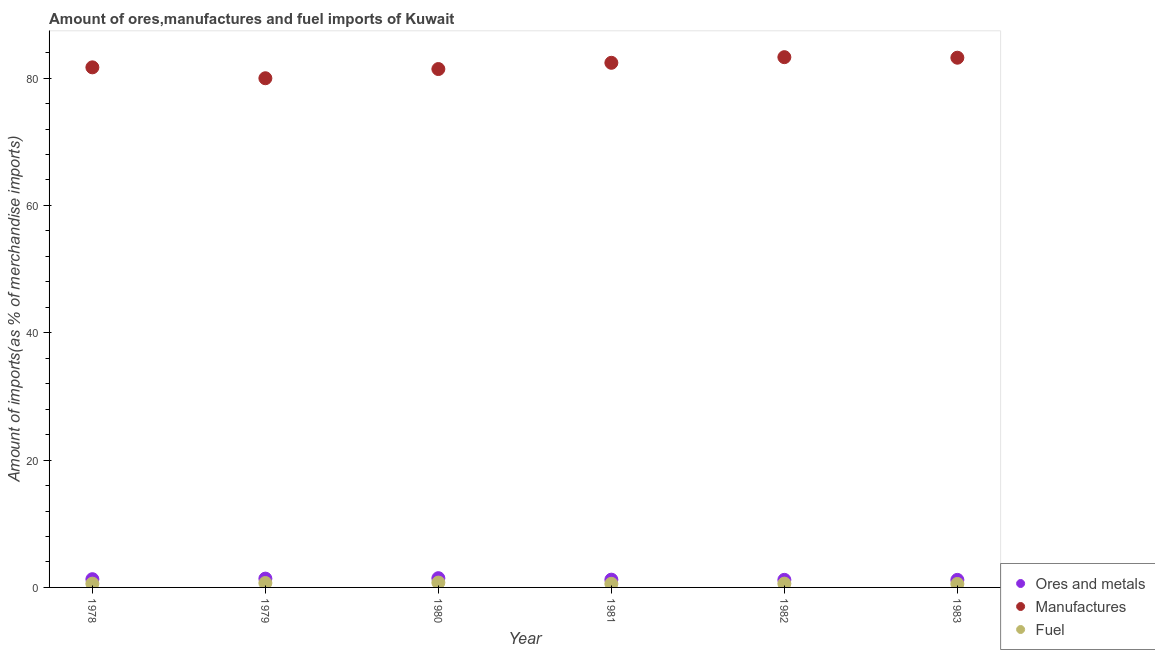Is the number of dotlines equal to the number of legend labels?
Offer a very short reply. Yes. What is the percentage of fuel imports in 1978?
Keep it short and to the point. 0.59. Across all years, what is the maximum percentage of fuel imports?
Your answer should be compact. 0.76. Across all years, what is the minimum percentage of fuel imports?
Your answer should be compact. 0.54. What is the total percentage of ores and metals imports in the graph?
Provide a short and direct response. 7.72. What is the difference between the percentage of ores and metals imports in 1980 and that in 1983?
Your response must be concise. 0.27. What is the difference between the percentage of manufactures imports in 1981 and the percentage of fuel imports in 1983?
Offer a very short reply. 81.86. What is the average percentage of fuel imports per year?
Give a very brief answer. 0.63. In the year 1978, what is the difference between the percentage of manufactures imports and percentage of ores and metals imports?
Give a very brief answer. 80.4. In how many years, is the percentage of ores and metals imports greater than 44 %?
Offer a very short reply. 0. What is the ratio of the percentage of fuel imports in 1979 to that in 1982?
Give a very brief answer. 1.16. Is the percentage of manufactures imports in 1979 less than that in 1982?
Provide a succinct answer. Yes. What is the difference between the highest and the second highest percentage of manufactures imports?
Your response must be concise. 0.08. What is the difference between the highest and the lowest percentage of ores and metals imports?
Keep it short and to the point. 0.27. Is the sum of the percentage of ores and metals imports in 1978 and 1979 greater than the maximum percentage of manufactures imports across all years?
Offer a very short reply. No. Is it the case that in every year, the sum of the percentage of ores and metals imports and percentage of manufactures imports is greater than the percentage of fuel imports?
Offer a very short reply. Yes. Does the percentage of fuel imports monotonically increase over the years?
Provide a succinct answer. No. Is the percentage of manufactures imports strictly greater than the percentage of ores and metals imports over the years?
Ensure brevity in your answer.  Yes. Is the percentage of manufactures imports strictly less than the percentage of ores and metals imports over the years?
Your answer should be very brief. No. How many years are there in the graph?
Your answer should be very brief. 6. Are the values on the major ticks of Y-axis written in scientific E-notation?
Give a very brief answer. No. Does the graph contain grids?
Keep it short and to the point. No. How many legend labels are there?
Provide a short and direct response. 3. How are the legend labels stacked?
Offer a very short reply. Vertical. What is the title of the graph?
Your answer should be very brief. Amount of ores,manufactures and fuel imports of Kuwait. What is the label or title of the X-axis?
Provide a short and direct response. Year. What is the label or title of the Y-axis?
Give a very brief answer. Amount of imports(as % of merchandise imports). What is the Amount of imports(as % of merchandise imports) in Ores and metals in 1978?
Provide a short and direct response. 1.29. What is the Amount of imports(as % of merchandise imports) of Manufactures in 1978?
Your response must be concise. 81.69. What is the Amount of imports(as % of merchandise imports) in Fuel in 1978?
Your response must be concise. 0.59. What is the Amount of imports(as % of merchandise imports) in Ores and metals in 1979?
Provide a short and direct response. 1.38. What is the Amount of imports(as % of merchandise imports) in Manufactures in 1979?
Provide a succinct answer. 79.98. What is the Amount of imports(as % of merchandise imports) of Fuel in 1979?
Your answer should be compact. 0.69. What is the Amount of imports(as % of merchandise imports) of Ores and metals in 1980?
Give a very brief answer. 1.45. What is the Amount of imports(as % of merchandise imports) of Manufactures in 1980?
Offer a very short reply. 81.43. What is the Amount of imports(as % of merchandise imports) in Fuel in 1980?
Provide a succinct answer. 0.76. What is the Amount of imports(as % of merchandise imports) in Ores and metals in 1981?
Your answer should be compact. 1.22. What is the Amount of imports(as % of merchandise imports) in Manufactures in 1981?
Provide a short and direct response. 82.41. What is the Amount of imports(as % of merchandise imports) in Fuel in 1981?
Your answer should be very brief. 0.57. What is the Amount of imports(as % of merchandise imports) in Ores and metals in 1982?
Your answer should be very brief. 1.19. What is the Amount of imports(as % of merchandise imports) in Manufactures in 1982?
Ensure brevity in your answer.  83.29. What is the Amount of imports(as % of merchandise imports) in Fuel in 1982?
Ensure brevity in your answer.  0.6. What is the Amount of imports(as % of merchandise imports) in Ores and metals in 1983?
Offer a very short reply. 1.19. What is the Amount of imports(as % of merchandise imports) in Manufactures in 1983?
Provide a succinct answer. 83.21. What is the Amount of imports(as % of merchandise imports) of Fuel in 1983?
Offer a terse response. 0.54. Across all years, what is the maximum Amount of imports(as % of merchandise imports) of Ores and metals?
Offer a very short reply. 1.45. Across all years, what is the maximum Amount of imports(as % of merchandise imports) of Manufactures?
Provide a short and direct response. 83.29. Across all years, what is the maximum Amount of imports(as % of merchandise imports) in Fuel?
Ensure brevity in your answer.  0.76. Across all years, what is the minimum Amount of imports(as % of merchandise imports) in Ores and metals?
Ensure brevity in your answer.  1.19. Across all years, what is the minimum Amount of imports(as % of merchandise imports) of Manufactures?
Give a very brief answer. 79.98. Across all years, what is the minimum Amount of imports(as % of merchandise imports) in Fuel?
Your answer should be compact. 0.54. What is the total Amount of imports(as % of merchandise imports) in Ores and metals in the graph?
Provide a short and direct response. 7.72. What is the total Amount of imports(as % of merchandise imports) in Manufactures in the graph?
Provide a short and direct response. 492. What is the total Amount of imports(as % of merchandise imports) in Fuel in the graph?
Your answer should be very brief. 3.76. What is the difference between the Amount of imports(as % of merchandise imports) of Ores and metals in 1978 and that in 1979?
Your answer should be compact. -0.09. What is the difference between the Amount of imports(as % of merchandise imports) in Manufactures in 1978 and that in 1979?
Keep it short and to the point. 1.71. What is the difference between the Amount of imports(as % of merchandise imports) of Fuel in 1978 and that in 1979?
Your answer should be compact. -0.1. What is the difference between the Amount of imports(as % of merchandise imports) in Ores and metals in 1978 and that in 1980?
Offer a terse response. -0.16. What is the difference between the Amount of imports(as % of merchandise imports) of Manufactures in 1978 and that in 1980?
Ensure brevity in your answer.  0.27. What is the difference between the Amount of imports(as % of merchandise imports) in Fuel in 1978 and that in 1980?
Provide a short and direct response. -0.17. What is the difference between the Amount of imports(as % of merchandise imports) of Ores and metals in 1978 and that in 1981?
Keep it short and to the point. 0.07. What is the difference between the Amount of imports(as % of merchandise imports) in Manufactures in 1978 and that in 1981?
Give a very brief answer. -0.71. What is the difference between the Amount of imports(as % of merchandise imports) in Fuel in 1978 and that in 1981?
Keep it short and to the point. 0.02. What is the difference between the Amount of imports(as % of merchandise imports) in Ores and metals in 1978 and that in 1982?
Provide a short and direct response. 0.1. What is the difference between the Amount of imports(as % of merchandise imports) in Manufactures in 1978 and that in 1982?
Offer a very short reply. -1.6. What is the difference between the Amount of imports(as % of merchandise imports) in Fuel in 1978 and that in 1982?
Your answer should be very brief. -0.01. What is the difference between the Amount of imports(as % of merchandise imports) in Ores and metals in 1978 and that in 1983?
Make the answer very short. 0.11. What is the difference between the Amount of imports(as % of merchandise imports) in Manufactures in 1978 and that in 1983?
Offer a terse response. -1.51. What is the difference between the Amount of imports(as % of merchandise imports) of Fuel in 1978 and that in 1983?
Keep it short and to the point. 0.05. What is the difference between the Amount of imports(as % of merchandise imports) in Ores and metals in 1979 and that in 1980?
Provide a short and direct response. -0.07. What is the difference between the Amount of imports(as % of merchandise imports) in Manufactures in 1979 and that in 1980?
Your answer should be compact. -1.45. What is the difference between the Amount of imports(as % of merchandise imports) of Fuel in 1979 and that in 1980?
Keep it short and to the point. -0.07. What is the difference between the Amount of imports(as % of merchandise imports) in Ores and metals in 1979 and that in 1981?
Give a very brief answer. 0.16. What is the difference between the Amount of imports(as % of merchandise imports) in Manufactures in 1979 and that in 1981?
Ensure brevity in your answer.  -2.43. What is the difference between the Amount of imports(as % of merchandise imports) in Fuel in 1979 and that in 1981?
Make the answer very short. 0.12. What is the difference between the Amount of imports(as % of merchandise imports) in Ores and metals in 1979 and that in 1982?
Keep it short and to the point. 0.19. What is the difference between the Amount of imports(as % of merchandise imports) in Manufactures in 1979 and that in 1982?
Keep it short and to the point. -3.31. What is the difference between the Amount of imports(as % of merchandise imports) of Fuel in 1979 and that in 1982?
Offer a terse response. 0.1. What is the difference between the Amount of imports(as % of merchandise imports) in Ores and metals in 1979 and that in 1983?
Your answer should be compact. 0.2. What is the difference between the Amount of imports(as % of merchandise imports) of Manufactures in 1979 and that in 1983?
Ensure brevity in your answer.  -3.23. What is the difference between the Amount of imports(as % of merchandise imports) of Fuel in 1979 and that in 1983?
Give a very brief answer. 0.15. What is the difference between the Amount of imports(as % of merchandise imports) in Ores and metals in 1980 and that in 1981?
Provide a short and direct response. 0.23. What is the difference between the Amount of imports(as % of merchandise imports) in Manufactures in 1980 and that in 1981?
Keep it short and to the point. -0.98. What is the difference between the Amount of imports(as % of merchandise imports) in Fuel in 1980 and that in 1981?
Give a very brief answer. 0.19. What is the difference between the Amount of imports(as % of merchandise imports) of Ores and metals in 1980 and that in 1982?
Offer a terse response. 0.26. What is the difference between the Amount of imports(as % of merchandise imports) of Manufactures in 1980 and that in 1982?
Give a very brief answer. -1.87. What is the difference between the Amount of imports(as % of merchandise imports) of Fuel in 1980 and that in 1982?
Ensure brevity in your answer.  0.16. What is the difference between the Amount of imports(as % of merchandise imports) in Ores and metals in 1980 and that in 1983?
Make the answer very short. 0.27. What is the difference between the Amount of imports(as % of merchandise imports) in Manufactures in 1980 and that in 1983?
Ensure brevity in your answer.  -1.78. What is the difference between the Amount of imports(as % of merchandise imports) in Fuel in 1980 and that in 1983?
Offer a terse response. 0.22. What is the difference between the Amount of imports(as % of merchandise imports) in Ores and metals in 1981 and that in 1982?
Keep it short and to the point. 0.03. What is the difference between the Amount of imports(as % of merchandise imports) in Manufactures in 1981 and that in 1982?
Provide a succinct answer. -0.88. What is the difference between the Amount of imports(as % of merchandise imports) of Fuel in 1981 and that in 1982?
Offer a very short reply. -0.03. What is the difference between the Amount of imports(as % of merchandise imports) in Ores and metals in 1981 and that in 1983?
Your answer should be very brief. 0.03. What is the difference between the Amount of imports(as % of merchandise imports) in Manufactures in 1981 and that in 1983?
Keep it short and to the point. -0.8. What is the difference between the Amount of imports(as % of merchandise imports) of Fuel in 1981 and that in 1983?
Make the answer very short. 0.02. What is the difference between the Amount of imports(as % of merchandise imports) of Ores and metals in 1982 and that in 1983?
Your answer should be compact. 0.01. What is the difference between the Amount of imports(as % of merchandise imports) of Manufactures in 1982 and that in 1983?
Your answer should be very brief. 0.08. What is the difference between the Amount of imports(as % of merchandise imports) of Fuel in 1982 and that in 1983?
Provide a short and direct response. 0.05. What is the difference between the Amount of imports(as % of merchandise imports) in Ores and metals in 1978 and the Amount of imports(as % of merchandise imports) in Manufactures in 1979?
Your answer should be compact. -78.69. What is the difference between the Amount of imports(as % of merchandise imports) of Ores and metals in 1978 and the Amount of imports(as % of merchandise imports) of Fuel in 1979?
Give a very brief answer. 0.6. What is the difference between the Amount of imports(as % of merchandise imports) of Manufactures in 1978 and the Amount of imports(as % of merchandise imports) of Fuel in 1979?
Keep it short and to the point. 81. What is the difference between the Amount of imports(as % of merchandise imports) of Ores and metals in 1978 and the Amount of imports(as % of merchandise imports) of Manufactures in 1980?
Offer a terse response. -80.13. What is the difference between the Amount of imports(as % of merchandise imports) in Ores and metals in 1978 and the Amount of imports(as % of merchandise imports) in Fuel in 1980?
Make the answer very short. 0.53. What is the difference between the Amount of imports(as % of merchandise imports) in Manufactures in 1978 and the Amount of imports(as % of merchandise imports) in Fuel in 1980?
Give a very brief answer. 80.93. What is the difference between the Amount of imports(as % of merchandise imports) of Ores and metals in 1978 and the Amount of imports(as % of merchandise imports) of Manufactures in 1981?
Give a very brief answer. -81.11. What is the difference between the Amount of imports(as % of merchandise imports) in Ores and metals in 1978 and the Amount of imports(as % of merchandise imports) in Fuel in 1981?
Offer a terse response. 0.72. What is the difference between the Amount of imports(as % of merchandise imports) in Manufactures in 1978 and the Amount of imports(as % of merchandise imports) in Fuel in 1981?
Offer a terse response. 81.12. What is the difference between the Amount of imports(as % of merchandise imports) in Ores and metals in 1978 and the Amount of imports(as % of merchandise imports) in Manufactures in 1982?
Keep it short and to the point. -82. What is the difference between the Amount of imports(as % of merchandise imports) of Ores and metals in 1978 and the Amount of imports(as % of merchandise imports) of Fuel in 1982?
Offer a very short reply. 0.7. What is the difference between the Amount of imports(as % of merchandise imports) of Manufactures in 1978 and the Amount of imports(as % of merchandise imports) of Fuel in 1982?
Make the answer very short. 81.09. What is the difference between the Amount of imports(as % of merchandise imports) in Ores and metals in 1978 and the Amount of imports(as % of merchandise imports) in Manufactures in 1983?
Your answer should be very brief. -81.91. What is the difference between the Amount of imports(as % of merchandise imports) in Ores and metals in 1978 and the Amount of imports(as % of merchandise imports) in Fuel in 1983?
Your answer should be compact. 0.75. What is the difference between the Amount of imports(as % of merchandise imports) of Manufactures in 1978 and the Amount of imports(as % of merchandise imports) of Fuel in 1983?
Your answer should be compact. 81.15. What is the difference between the Amount of imports(as % of merchandise imports) in Ores and metals in 1979 and the Amount of imports(as % of merchandise imports) in Manufactures in 1980?
Provide a succinct answer. -80.04. What is the difference between the Amount of imports(as % of merchandise imports) of Ores and metals in 1979 and the Amount of imports(as % of merchandise imports) of Fuel in 1980?
Keep it short and to the point. 0.62. What is the difference between the Amount of imports(as % of merchandise imports) in Manufactures in 1979 and the Amount of imports(as % of merchandise imports) in Fuel in 1980?
Offer a very short reply. 79.22. What is the difference between the Amount of imports(as % of merchandise imports) of Ores and metals in 1979 and the Amount of imports(as % of merchandise imports) of Manufactures in 1981?
Your answer should be compact. -81.02. What is the difference between the Amount of imports(as % of merchandise imports) in Ores and metals in 1979 and the Amount of imports(as % of merchandise imports) in Fuel in 1981?
Your answer should be compact. 0.81. What is the difference between the Amount of imports(as % of merchandise imports) of Manufactures in 1979 and the Amount of imports(as % of merchandise imports) of Fuel in 1981?
Offer a very short reply. 79.41. What is the difference between the Amount of imports(as % of merchandise imports) in Ores and metals in 1979 and the Amount of imports(as % of merchandise imports) in Manufactures in 1982?
Ensure brevity in your answer.  -81.91. What is the difference between the Amount of imports(as % of merchandise imports) of Ores and metals in 1979 and the Amount of imports(as % of merchandise imports) of Fuel in 1982?
Keep it short and to the point. 0.79. What is the difference between the Amount of imports(as % of merchandise imports) of Manufactures in 1979 and the Amount of imports(as % of merchandise imports) of Fuel in 1982?
Give a very brief answer. 79.38. What is the difference between the Amount of imports(as % of merchandise imports) in Ores and metals in 1979 and the Amount of imports(as % of merchandise imports) in Manufactures in 1983?
Your answer should be compact. -81.82. What is the difference between the Amount of imports(as % of merchandise imports) in Ores and metals in 1979 and the Amount of imports(as % of merchandise imports) in Fuel in 1983?
Your response must be concise. 0.84. What is the difference between the Amount of imports(as % of merchandise imports) of Manufactures in 1979 and the Amount of imports(as % of merchandise imports) of Fuel in 1983?
Your response must be concise. 79.43. What is the difference between the Amount of imports(as % of merchandise imports) of Ores and metals in 1980 and the Amount of imports(as % of merchandise imports) of Manufactures in 1981?
Offer a very short reply. -80.95. What is the difference between the Amount of imports(as % of merchandise imports) in Ores and metals in 1980 and the Amount of imports(as % of merchandise imports) in Fuel in 1981?
Your answer should be very brief. 0.88. What is the difference between the Amount of imports(as % of merchandise imports) in Manufactures in 1980 and the Amount of imports(as % of merchandise imports) in Fuel in 1981?
Ensure brevity in your answer.  80.86. What is the difference between the Amount of imports(as % of merchandise imports) of Ores and metals in 1980 and the Amount of imports(as % of merchandise imports) of Manufactures in 1982?
Make the answer very short. -81.84. What is the difference between the Amount of imports(as % of merchandise imports) in Ores and metals in 1980 and the Amount of imports(as % of merchandise imports) in Fuel in 1982?
Offer a very short reply. 0.85. What is the difference between the Amount of imports(as % of merchandise imports) of Manufactures in 1980 and the Amount of imports(as % of merchandise imports) of Fuel in 1982?
Your answer should be compact. 80.83. What is the difference between the Amount of imports(as % of merchandise imports) of Ores and metals in 1980 and the Amount of imports(as % of merchandise imports) of Manufactures in 1983?
Keep it short and to the point. -81.75. What is the difference between the Amount of imports(as % of merchandise imports) of Ores and metals in 1980 and the Amount of imports(as % of merchandise imports) of Fuel in 1983?
Keep it short and to the point. 0.91. What is the difference between the Amount of imports(as % of merchandise imports) in Manufactures in 1980 and the Amount of imports(as % of merchandise imports) in Fuel in 1983?
Give a very brief answer. 80.88. What is the difference between the Amount of imports(as % of merchandise imports) of Ores and metals in 1981 and the Amount of imports(as % of merchandise imports) of Manufactures in 1982?
Your answer should be very brief. -82.07. What is the difference between the Amount of imports(as % of merchandise imports) of Ores and metals in 1981 and the Amount of imports(as % of merchandise imports) of Fuel in 1982?
Provide a short and direct response. 0.62. What is the difference between the Amount of imports(as % of merchandise imports) of Manufactures in 1981 and the Amount of imports(as % of merchandise imports) of Fuel in 1982?
Ensure brevity in your answer.  81.81. What is the difference between the Amount of imports(as % of merchandise imports) of Ores and metals in 1981 and the Amount of imports(as % of merchandise imports) of Manufactures in 1983?
Your answer should be very brief. -81.99. What is the difference between the Amount of imports(as % of merchandise imports) in Ores and metals in 1981 and the Amount of imports(as % of merchandise imports) in Fuel in 1983?
Ensure brevity in your answer.  0.68. What is the difference between the Amount of imports(as % of merchandise imports) in Manufactures in 1981 and the Amount of imports(as % of merchandise imports) in Fuel in 1983?
Provide a short and direct response. 81.86. What is the difference between the Amount of imports(as % of merchandise imports) of Ores and metals in 1982 and the Amount of imports(as % of merchandise imports) of Manufactures in 1983?
Offer a terse response. -82.02. What is the difference between the Amount of imports(as % of merchandise imports) of Ores and metals in 1982 and the Amount of imports(as % of merchandise imports) of Fuel in 1983?
Make the answer very short. 0.65. What is the difference between the Amount of imports(as % of merchandise imports) in Manufactures in 1982 and the Amount of imports(as % of merchandise imports) in Fuel in 1983?
Your answer should be very brief. 82.75. What is the average Amount of imports(as % of merchandise imports) of Ores and metals per year?
Give a very brief answer. 1.29. What is the average Amount of imports(as % of merchandise imports) of Manufactures per year?
Give a very brief answer. 82. What is the average Amount of imports(as % of merchandise imports) of Fuel per year?
Your answer should be compact. 0.63. In the year 1978, what is the difference between the Amount of imports(as % of merchandise imports) in Ores and metals and Amount of imports(as % of merchandise imports) in Manufactures?
Offer a very short reply. -80.4. In the year 1978, what is the difference between the Amount of imports(as % of merchandise imports) of Ores and metals and Amount of imports(as % of merchandise imports) of Fuel?
Give a very brief answer. 0.7. In the year 1978, what is the difference between the Amount of imports(as % of merchandise imports) in Manufactures and Amount of imports(as % of merchandise imports) in Fuel?
Make the answer very short. 81.1. In the year 1979, what is the difference between the Amount of imports(as % of merchandise imports) in Ores and metals and Amount of imports(as % of merchandise imports) in Manufactures?
Your response must be concise. -78.6. In the year 1979, what is the difference between the Amount of imports(as % of merchandise imports) of Ores and metals and Amount of imports(as % of merchandise imports) of Fuel?
Give a very brief answer. 0.69. In the year 1979, what is the difference between the Amount of imports(as % of merchandise imports) in Manufactures and Amount of imports(as % of merchandise imports) in Fuel?
Provide a succinct answer. 79.29. In the year 1980, what is the difference between the Amount of imports(as % of merchandise imports) in Ores and metals and Amount of imports(as % of merchandise imports) in Manufactures?
Offer a terse response. -79.97. In the year 1980, what is the difference between the Amount of imports(as % of merchandise imports) of Ores and metals and Amount of imports(as % of merchandise imports) of Fuel?
Keep it short and to the point. 0.69. In the year 1980, what is the difference between the Amount of imports(as % of merchandise imports) in Manufactures and Amount of imports(as % of merchandise imports) in Fuel?
Make the answer very short. 80.66. In the year 1981, what is the difference between the Amount of imports(as % of merchandise imports) in Ores and metals and Amount of imports(as % of merchandise imports) in Manufactures?
Your answer should be very brief. -81.19. In the year 1981, what is the difference between the Amount of imports(as % of merchandise imports) of Ores and metals and Amount of imports(as % of merchandise imports) of Fuel?
Offer a very short reply. 0.65. In the year 1981, what is the difference between the Amount of imports(as % of merchandise imports) in Manufactures and Amount of imports(as % of merchandise imports) in Fuel?
Make the answer very short. 81.84. In the year 1982, what is the difference between the Amount of imports(as % of merchandise imports) in Ores and metals and Amount of imports(as % of merchandise imports) in Manufactures?
Provide a succinct answer. -82.1. In the year 1982, what is the difference between the Amount of imports(as % of merchandise imports) of Ores and metals and Amount of imports(as % of merchandise imports) of Fuel?
Ensure brevity in your answer.  0.59. In the year 1982, what is the difference between the Amount of imports(as % of merchandise imports) in Manufactures and Amount of imports(as % of merchandise imports) in Fuel?
Offer a terse response. 82.69. In the year 1983, what is the difference between the Amount of imports(as % of merchandise imports) of Ores and metals and Amount of imports(as % of merchandise imports) of Manufactures?
Give a very brief answer. -82.02. In the year 1983, what is the difference between the Amount of imports(as % of merchandise imports) in Ores and metals and Amount of imports(as % of merchandise imports) in Fuel?
Your answer should be compact. 0.64. In the year 1983, what is the difference between the Amount of imports(as % of merchandise imports) of Manufactures and Amount of imports(as % of merchandise imports) of Fuel?
Keep it short and to the point. 82.66. What is the ratio of the Amount of imports(as % of merchandise imports) of Ores and metals in 1978 to that in 1979?
Provide a short and direct response. 0.93. What is the ratio of the Amount of imports(as % of merchandise imports) of Manufactures in 1978 to that in 1979?
Your answer should be very brief. 1.02. What is the ratio of the Amount of imports(as % of merchandise imports) in Fuel in 1978 to that in 1979?
Make the answer very short. 0.85. What is the ratio of the Amount of imports(as % of merchandise imports) of Ores and metals in 1978 to that in 1980?
Provide a succinct answer. 0.89. What is the ratio of the Amount of imports(as % of merchandise imports) in Fuel in 1978 to that in 1980?
Make the answer very short. 0.78. What is the ratio of the Amount of imports(as % of merchandise imports) in Ores and metals in 1978 to that in 1981?
Provide a succinct answer. 1.06. What is the ratio of the Amount of imports(as % of merchandise imports) in Fuel in 1978 to that in 1981?
Provide a short and direct response. 1.04. What is the ratio of the Amount of imports(as % of merchandise imports) of Ores and metals in 1978 to that in 1982?
Make the answer very short. 1.09. What is the ratio of the Amount of imports(as % of merchandise imports) in Manufactures in 1978 to that in 1982?
Your response must be concise. 0.98. What is the ratio of the Amount of imports(as % of merchandise imports) of Ores and metals in 1978 to that in 1983?
Give a very brief answer. 1.09. What is the ratio of the Amount of imports(as % of merchandise imports) in Manufactures in 1978 to that in 1983?
Provide a short and direct response. 0.98. What is the ratio of the Amount of imports(as % of merchandise imports) in Fuel in 1978 to that in 1983?
Ensure brevity in your answer.  1.09. What is the ratio of the Amount of imports(as % of merchandise imports) of Ores and metals in 1979 to that in 1980?
Ensure brevity in your answer.  0.95. What is the ratio of the Amount of imports(as % of merchandise imports) of Manufactures in 1979 to that in 1980?
Provide a short and direct response. 0.98. What is the ratio of the Amount of imports(as % of merchandise imports) in Fuel in 1979 to that in 1980?
Your answer should be very brief. 0.91. What is the ratio of the Amount of imports(as % of merchandise imports) of Ores and metals in 1979 to that in 1981?
Ensure brevity in your answer.  1.13. What is the ratio of the Amount of imports(as % of merchandise imports) in Manufactures in 1979 to that in 1981?
Give a very brief answer. 0.97. What is the ratio of the Amount of imports(as % of merchandise imports) of Fuel in 1979 to that in 1981?
Give a very brief answer. 1.22. What is the ratio of the Amount of imports(as % of merchandise imports) of Ores and metals in 1979 to that in 1982?
Make the answer very short. 1.16. What is the ratio of the Amount of imports(as % of merchandise imports) in Manufactures in 1979 to that in 1982?
Offer a very short reply. 0.96. What is the ratio of the Amount of imports(as % of merchandise imports) of Fuel in 1979 to that in 1982?
Keep it short and to the point. 1.16. What is the ratio of the Amount of imports(as % of merchandise imports) in Ores and metals in 1979 to that in 1983?
Offer a very short reply. 1.17. What is the ratio of the Amount of imports(as % of merchandise imports) of Manufactures in 1979 to that in 1983?
Ensure brevity in your answer.  0.96. What is the ratio of the Amount of imports(as % of merchandise imports) in Fuel in 1979 to that in 1983?
Your response must be concise. 1.27. What is the ratio of the Amount of imports(as % of merchandise imports) of Ores and metals in 1980 to that in 1981?
Offer a terse response. 1.19. What is the ratio of the Amount of imports(as % of merchandise imports) in Fuel in 1980 to that in 1981?
Offer a terse response. 1.34. What is the ratio of the Amount of imports(as % of merchandise imports) of Ores and metals in 1980 to that in 1982?
Offer a terse response. 1.22. What is the ratio of the Amount of imports(as % of merchandise imports) in Manufactures in 1980 to that in 1982?
Your response must be concise. 0.98. What is the ratio of the Amount of imports(as % of merchandise imports) in Fuel in 1980 to that in 1982?
Your response must be concise. 1.27. What is the ratio of the Amount of imports(as % of merchandise imports) in Ores and metals in 1980 to that in 1983?
Provide a succinct answer. 1.22. What is the ratio of the Amount of imports(as % of merchandise imports) in Manufactures in 1980 to that in 1983?
Your answer should be compact. 0.98. What is the ratio of the Amount of imports(as % of merchandise imports) of Fuel in 1980 to that in 1983?
Ensure brevity in your answer.  1.4. What is the ratio of the Amount of imports(as % of merchandise imports) in Ores and metals in 1981 to that in 1982?
Your answer should be very brief. 1.02. What is the ratio of the Amount of imports(as % of merchandise imports) in Fuel in 1981 to that in 1982?
Make the answer very short. 0.95. What is the ratio of the Amount of imports(as % of merchandise imports) of Ores and metals in 1981 to that in 1983?
Provide a succinct answer. 1.03. What is the ratio of the Amount of imports(as % of merchandise imports) in Manufactures in 1981 to that in 1983?
Ensure brevity in your answer.  0.99. What is the ratio of the Amount of imports(as % of merchandise imports) in Fuel in 1981 to that in 1983?
Give a very brief answer. 1.04. What is the ratio of the Amount of imports(as % of merchandise imports) of Ores and metals in 1982 to that in 1983?
Ensure brevity in your answer.  1. What is the ratio of the Amount of imports(as % of merchandise imports) of Fuel in 1982 to that in 1983?
Offer a very short reply. 1.1. What is the difference between the highest and the second highest Amount of imports(as % of merchandise imports) of Ores and metals?
Give a very brief answer. 0.07. What is the difference between the highest and the second highest Amount of imports(as % of merchandise imports) in Manufactures?
Keep it short and to the point. 0.08. What is the difference between the highest and the second highest Amount of imports(as % of merchandise imports) in Fuel?
Offer a very short reply. 0.07. What is the difference between the highest and the lowest Amount of imports(as % of merchandise imports) in Ores and metals?
Your answer should be very brief. 0.27. What is the difference between the highest and the lowest Amount of imports(as % of merchandise imports) of Manufactures?
Ensure brevity in your answer.  3.31. What is the difference between the highest and the lowest Amount of imports(as % of merchandise imports) in Fuel?
Your response must be concise. 0.22. 